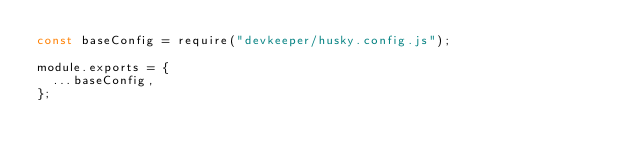<code> <loc_0><loc_0><loc_500><loc_500><_JavaScript_>const baseConfig = require("devkeeper/husky.config.js");

module.exports = {
  ...baseConfig,
};
</code> 